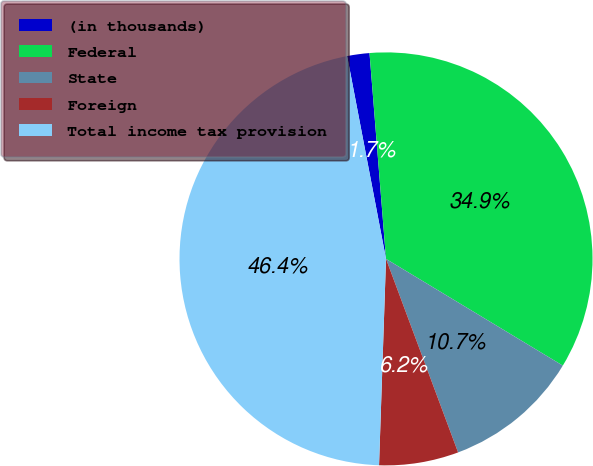Convert chart to OTSL. <chart><loc_0><loc_0><loc_500><loc_500><pie_chart><fcel>(in thousands)<fcel>Federal<fcel>State<fcel>Foreign<fcel>Total income tax provision<nl><fcel>1.74%<fcel>34.91%<fcel>10.68%<fcel>6.21%<fcel>46.44%<nl></chart> 